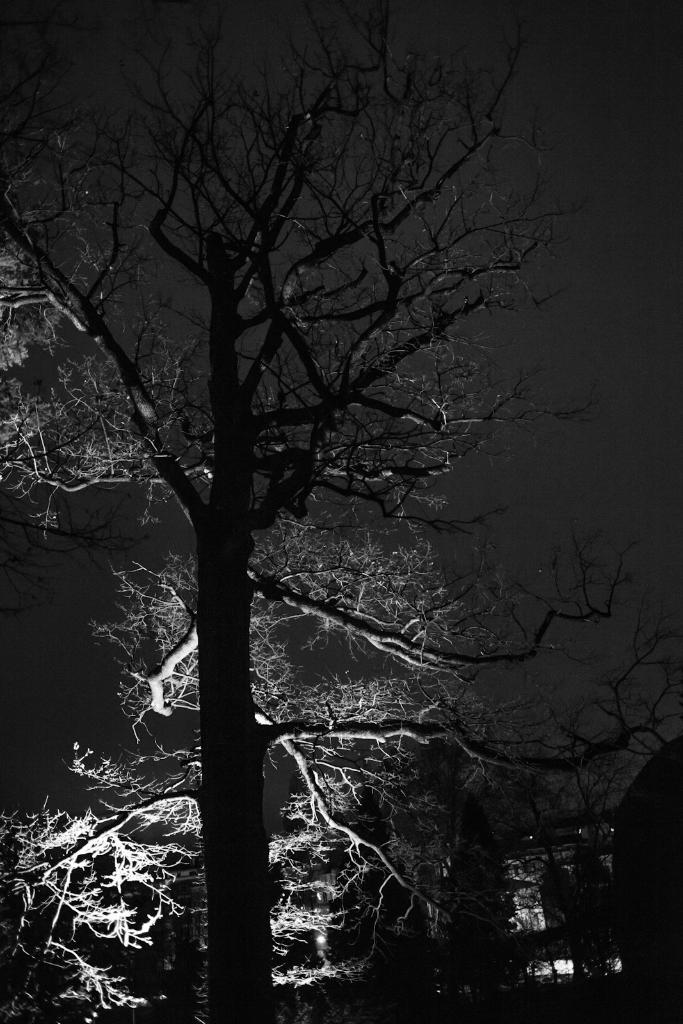What type of plant can be seen in the image? There is a tree in the image. What part of the natural environment is visible in the background of the image? The sky is visible in the background of the image. How many quinces are hanging from the tree in the image? There is no mention of quinces in the image; it only features a tree and the sky. 